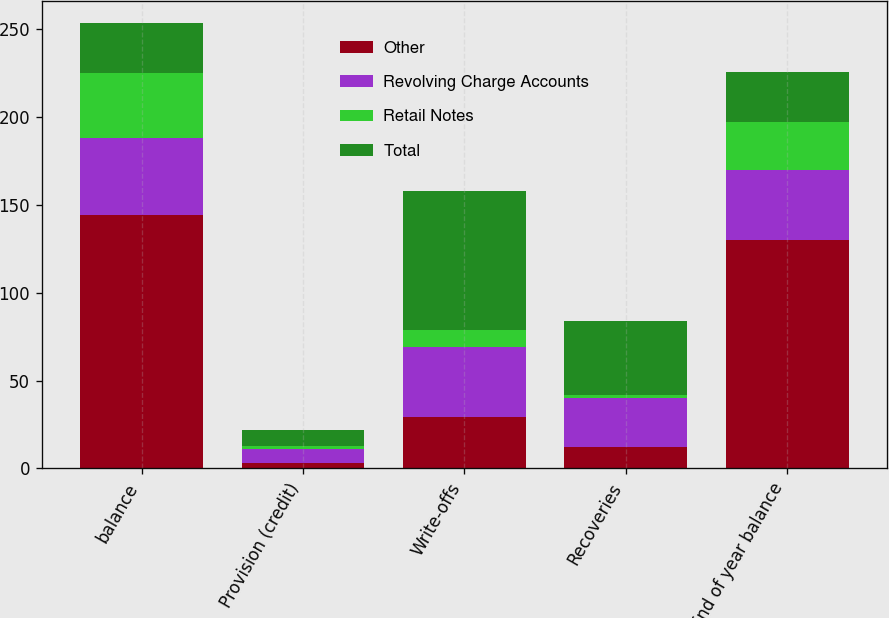<chart> <loc_0><loc_0><loc_500><loc_500><stacked_bar_chart><ecel><fcel>balance<fcel>Provision (credit)<fcel>Write-offs<fcel>Recoveries<fcel>End of year balance<nl><fcel>Other<fcel>144<fcel>3<fcel>29<fcel>12<fcel>130<nl><fcel>Revolving Charge Accounts<fcel>44<fcel>8<fcel>40<fcel>28<fcel>40<nl><fcel>Retail Notes<fcel>37<fcel>2<fcel>10<fcel>2<fcel>27<nl><fcel>Total<fcel>28.5<fcel>9<fcel>79<fcel>42<fcel>28.5<nl></chart> 